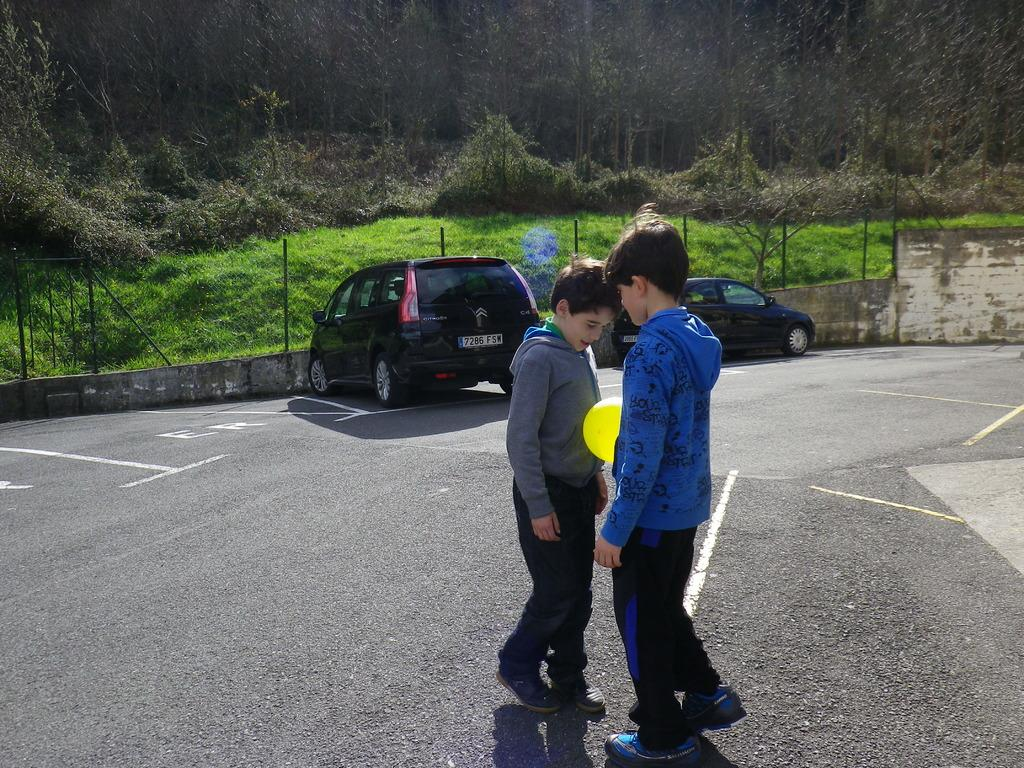How many boys are in the image? There are two boys in the image. Where are the boys located? The boys are on the road. What object is between the boys? There is a ball between the boys. What can be seen in the background of the image? Cars, a fence, metal rods, and trees can be seen in the background of the image. What type of bread is the dog eating in the image? There is no dog or bread present in the image. 